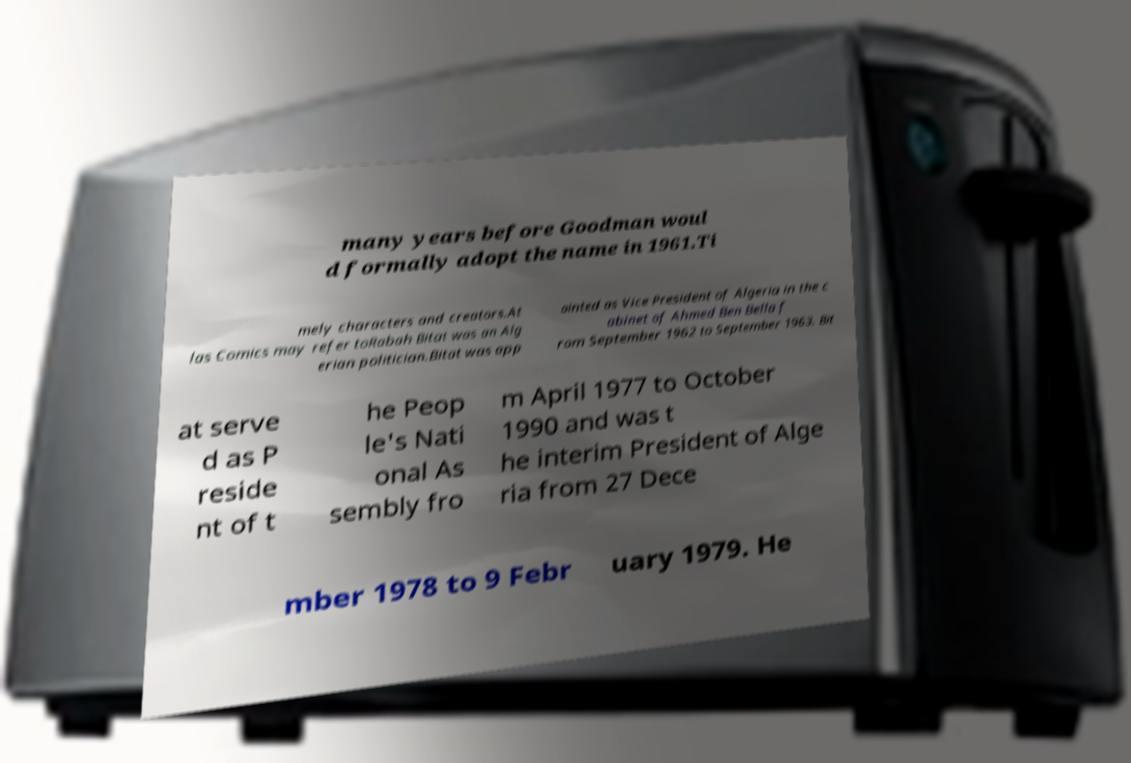Please identify and transcribe the text found in this image. many years before Goodman woul d formally adopt the name in 1961.Ti mely characters and creators.At las Comics may refer toRabah Bitat was an Alg erian politician.Bitat was app ointed as Vice President of Algeria in the c abinet of Ahmed Ben Bella f rom September 1962 to September 1963. Bit at serve d as P reside nt of t he Peop le's Nati onal As sembly fro m April 1977 to October 1990 and was t he interim President of Alge ria from 27 Dece mber 1978 to 9 Febr uary 1979. He 